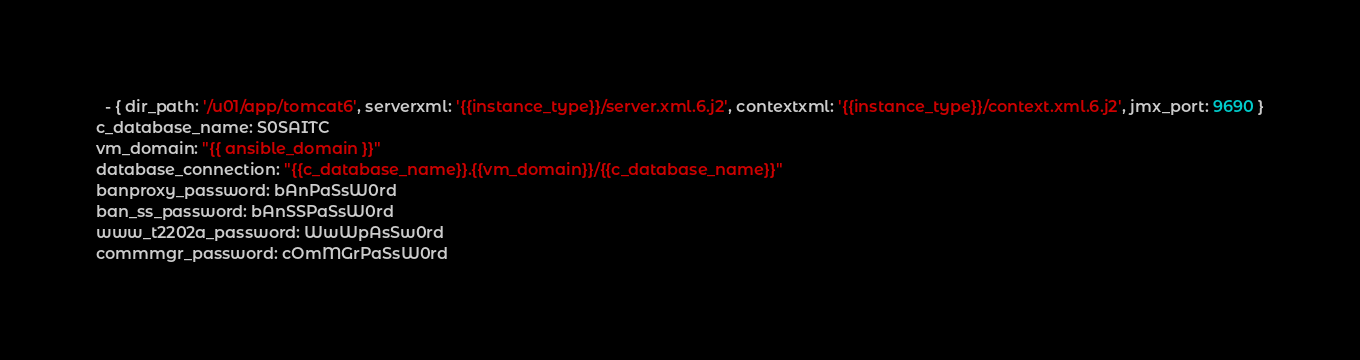Convert code to text. <code><loc_0><loc_0><loc_500><loc_500><_YAML_>  - { dir_path: '/u01/app/tomcat6', serverxml: '{{instance_type}}/server.xml.6.j2', contextxml: '{{instance_type}}/context.xml.6.j2', jmx_port: 9690 }
c_database_name: S0SAITC
vm_domain: "{{ ansible_domain }}"
database_connection: "{{c_database_name}}.{{vm_domain}}/{{c_database_name}}"
banproxy_password: bAnPaSsW0rd
ban_ss_password: bAnSSPaSsW0rd
www_t2202a_password: WwWpAsSw0rd
commmgr_password: cOmMGrPaSsW0rd</code> 